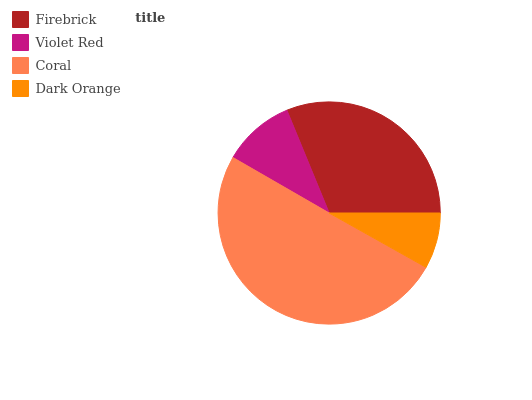Is Dark Orange the minimum?
Answer yes or no. Yes. Is Coral the maximum?
Answer yes or no. Yes. Is Violet Red the minimum?
Answer yes or no. No. Is Violet Red the maximum?
Answer yes or no. No. Is Firebrick greater than Violet Red?
Answer yes or no. Yes. Is Violet Red less than Firebrick?
Answer yes or no. Yes. Is Violet Red greater than Firebrick?
Answer yes or no. No. Is Firebrick less than Violet Red?
Answer yes or no. No. Is Firebrick the high median?
Answer yes or no. Yes. Is Violet Red the low median?
Answer yes or no. Yes. Is Violet Red the high median?
Answer yes or no. No. Is Coral the low median?
Answer yes or no. No. 